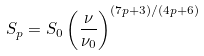Convert formula to latex. <formula><loc_0><loc_0><loc_500><loc_500>S _ { p } = S _ { 0 } \left ( \frac { \nu } { \nu _ { 0 } } \right ) ^ { ( 7 p + 3 ) / ( 4 p + 6 ) }</formula> 